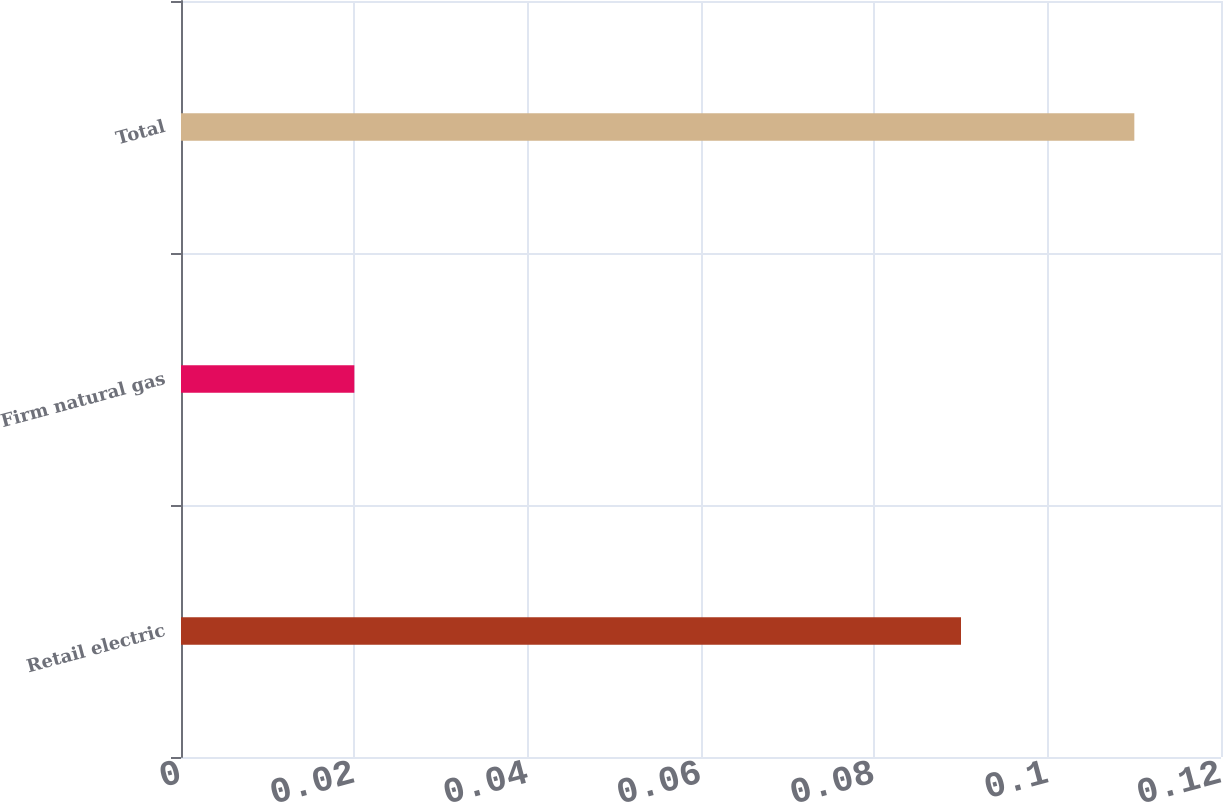Convert chart to OTSL. <chart><loc_0><loc_0><loc_500><loc_500><bar_chart><fcel>Retail electric<fcel>Firm natural gas<fcel>Total<nl><fcel>0.09<fcel>0.02<fcel>0.11<nl></chart> 